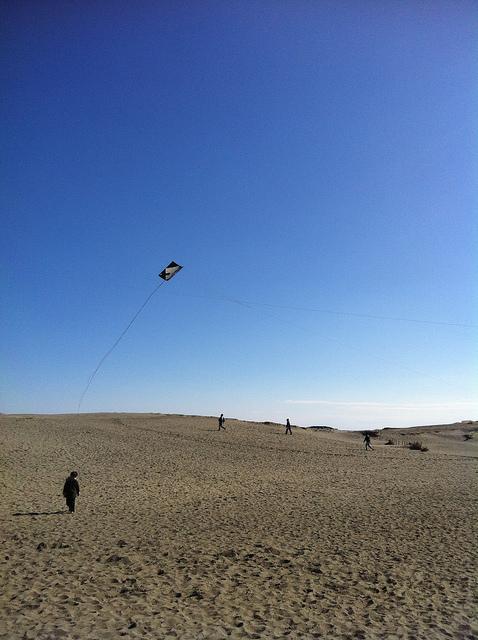Are there clouds in the sky?
Answer briefly. No. Where is a bridge?
Answer briefly. Usually placed over water. Was this photo taken near water?
Write a very short answer. No. Could you call this picture hazy?
Write a very short answer. No. Is the photo colored?
Keep it brief. Yes. Is it windy?
Quick response, please. Yes. Is there a bench to sit on?
Quick response, please. No. Could these kites get tangled up?
Give a very brief answer. No. What is the person on the left wearing?
Write a very short answer. Clothes. What does this photo encourage a person to delight in?
Be succinct. Kiting. How do you know if you should use this photo without the photographer's permission?
Give a very brief answer. Ask. Is it summer time?
Write a very short answer. Yes. Is this a color or black and white picture?
Answer briefly. Color. Is this an advert?
Give a very brief answer. No. What is the dog holding?
Concise answer only. Nothing. How many people are in this picture?
Short answer required. 4. Is the picture white and black?
Be succinct. No. Is there a reflection?
Write a very short answer. No. Is there grass in the picture?
Quick response, please. No. Is someone holding the kite on a string?
Short answer required. Yes. Do you see a bike?
Keep it brief. No. What is the color of the tail of the kite?
Short answer required. Black. Where is the Kite's tail?
Short answer required. Sky. How many dimples are in the sand?
Answer briefly. Thousands. Are there any seagulls in the air?
Concise answer only. No. What are the people standing on?
Be succinct. Sand. Where is the man?
Be succinct. Desert. Why are there clouds on the horizon?
Answer briefly. Unknown. Is this summer?
Give a very brief answer. Yes. What kind of formations are sticking out of the sand?
Answer briefly. None. Is the sky cloudless?
Quick response, please. Yes. What is the person standing on?
Concise answer only. Sand. Is it sunny outside?
Short answer required. Yes. Are there green plants?
Be succinct. No. What is this person doing?
Write a very short answer. Flying kite. 